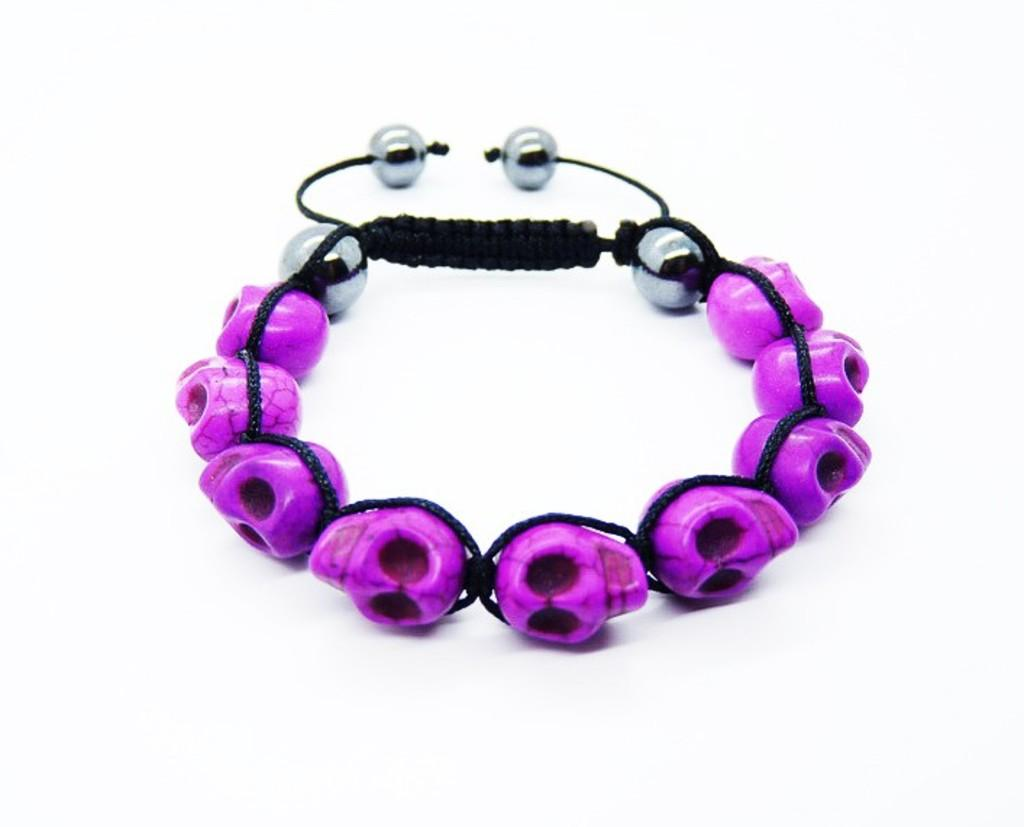What is the main subject of the picture? The main subject of the picture is a bracelet. What is the color of the bracelet? The bracelet is purple in color. What materials are used to make the bracelet? The bracelet is made up of purple and silver color beads and black color thread. What is the color of the background in the picture? The background of the picture is white in color. Can you tell me how many bears are holding a cannon in the image? There are no bears or cannons present in the image; it features a purple bracelet made up of purple and silver color beads and black color thread against a white background. What type of milk is being used to create the bracelet in the image? There is no milk involved in the creation of the bracelet in the image; it is made up of beads and thread. 